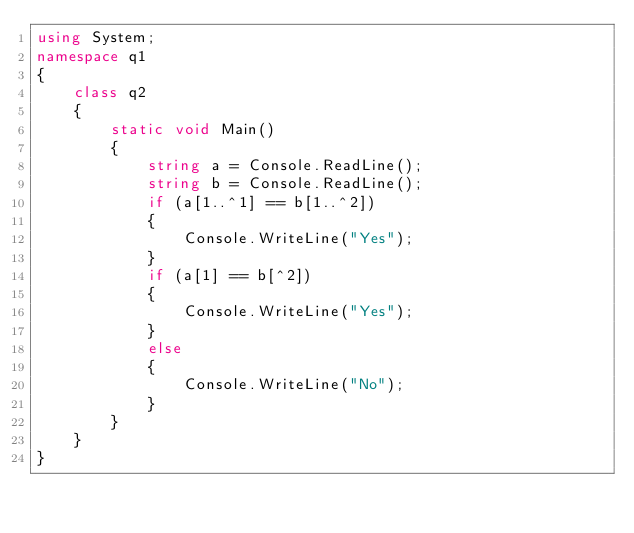<code> <loc_0><loc_0><loc_500><loc_500><_C#_>using System;
namespace q1
{
    class q2
    {
        static void Main()
        {
            string a = Console.ReadLine();
            string b = Console.ReadLine();
            if (a[1..^1] == b[1..^2])
            {
                Console.WriteLine("Yes");
            }
            if (a[1] == b[^2])
            {
                Console.WriteLine("Yes");
            }
            else
            {
                Console.WriteLine("No");
            }
        }
    }
}</code> 